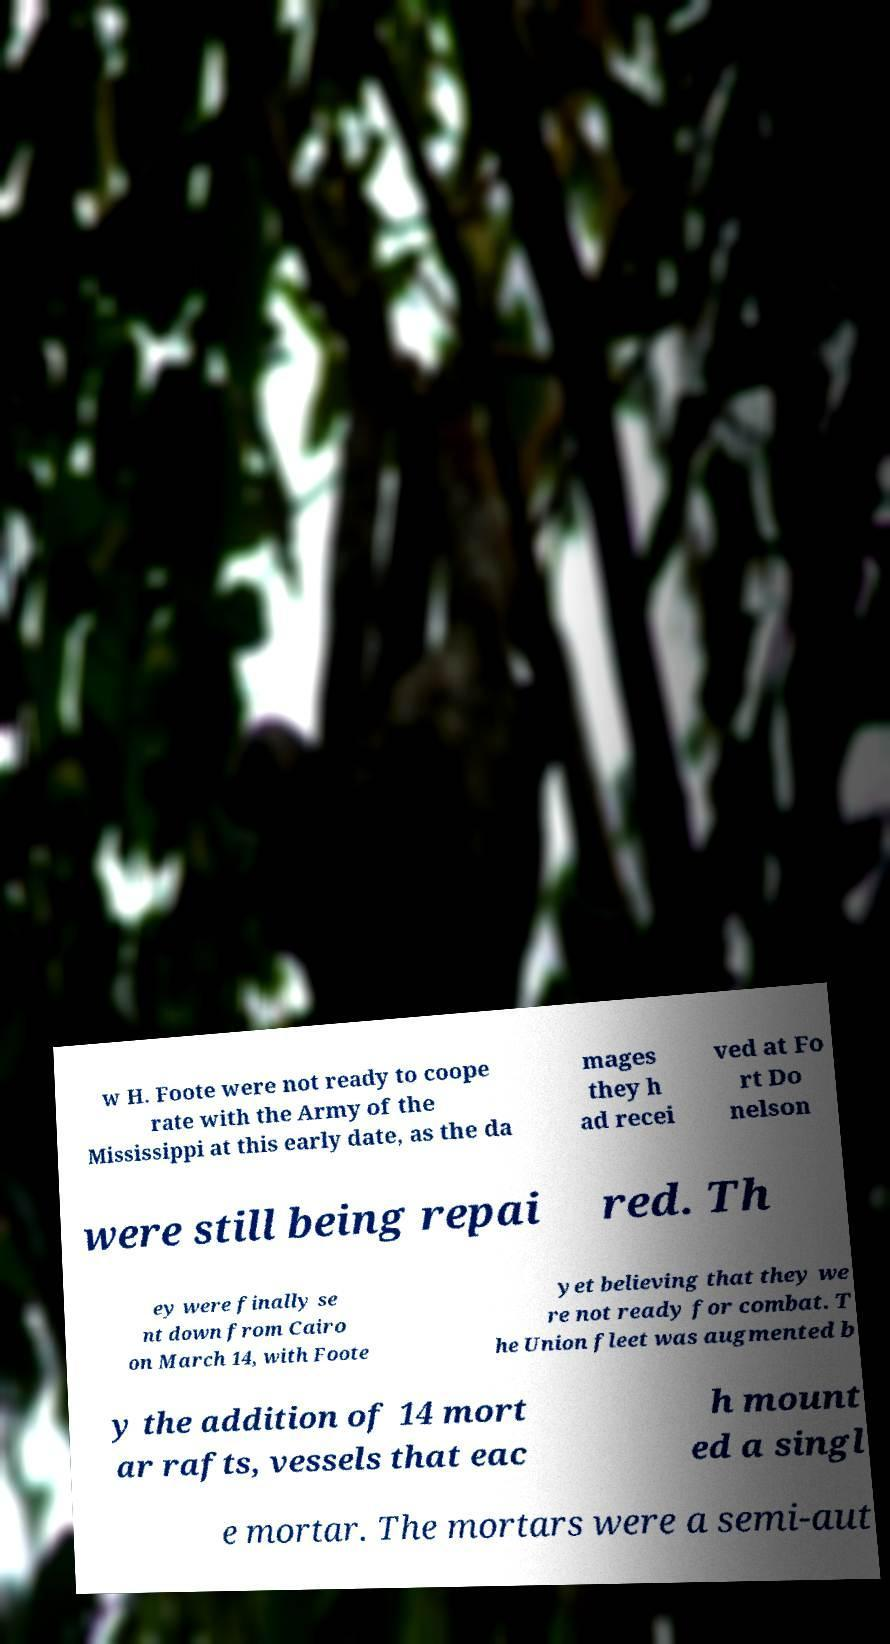Can you accurately transcribe the text from the provided image for me? w H. Foote were not ready to coope rate with the Army of the Mississippi at this early date, as the da mages they h ad recei ved at Fo rt Do nelson were still being repai red. Th ey were finally se nt down from Cairo on March 14, with Foote yet believing that they we re not ready for combat. T he Union fleet was augmented b y the addition of 14 mort ar rafts, vessels that eac h mount ed a singl e mortar. The mortars were a semi-aut 